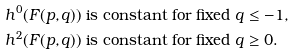Convert formula to latex. <formula><loc_0><loc_0><loc_500><loc_500>& h ^ { 0 } ( F ( p , q ) ) \text { is constant for fixed } q \leq - 1 , \\ & h ^ { 2 } ( F ( p , q ) ) \text { is constant for fixed } q \geq 0 .</formula> 